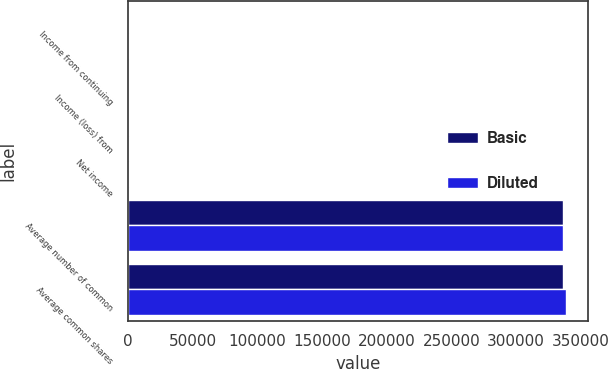Convert chart to OTSL. <chart><loc_0><loc_0><loc_500><loc_500><stacked_bar_chart><ecel><fcel>Income from continuing<fcel>Income (loss) from<fcel>Net income<fcel>Average number of common<fcel>Average common shares<nl><fcel>Basic<fcel>1257<fcel>4<fcel>1261<fcel>336485<fcel>336485<nl><fcel>Diluted<fcel>1257<fcel>4<fcel>1261<fcel>336485<fcel>338253<nl></chart> 